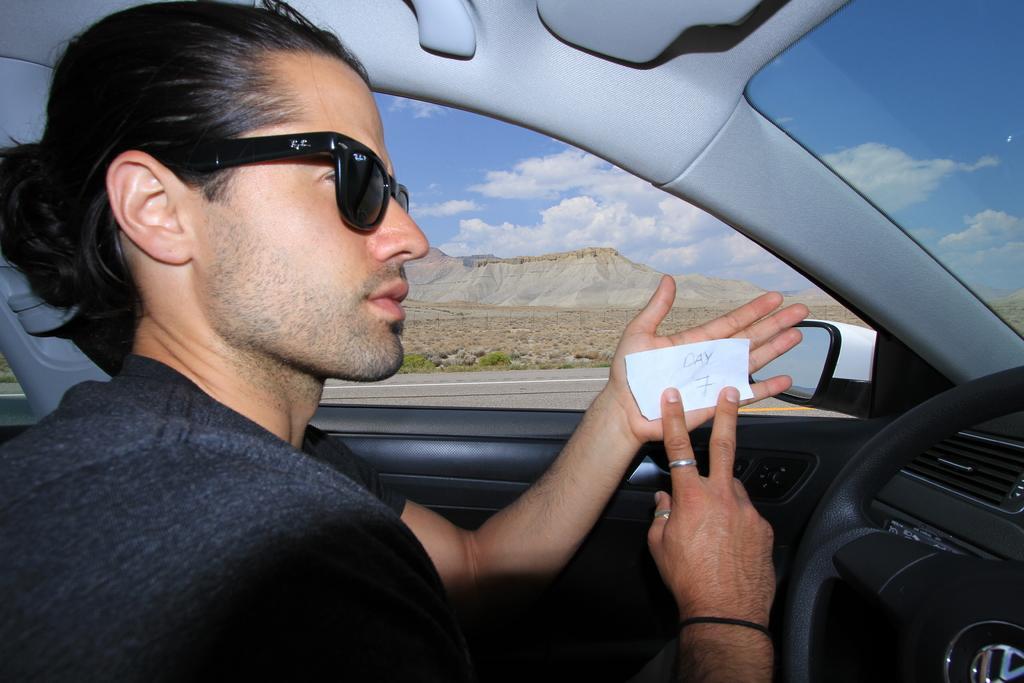In one or two sentences, can you explain what this image depicts? In this image I can see a man is sitting in a car. I can also see he is holding a paper and wearing a sunglasses. 